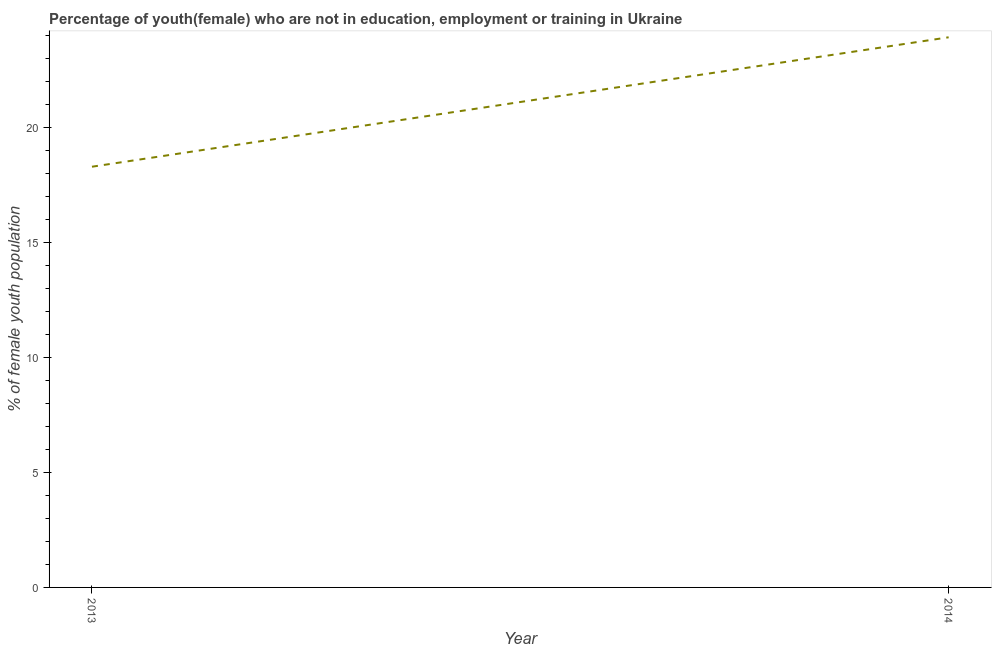What is the unemployed female youth population in 2013?
Provide a short and direct response. 18.3. Across all years, what is the maximum unemployed female youth population?
Ensure brevity in your answer.  23.93. Across all years, what is the minimum unemployed female youth population?
Provide a short and direct response. 18.3. In which year was the unemployed female youth population maximum?
Your response must be concise. 2014. In which year was the unemployed female youth population minimum?
Keep it short and to the point. 2013. What is the sum of the unemployed female youth population?
Keep it short and to the point. 42.23. What is the difference between the unemployed female youth population in 2013 and 2014?
Ensure brevity in your answer.  -5.63. What is the average unemployed female youth population per year?
Your answer should be compact. 21.11. What is the median unemployed female youth population?
Ensure brevity in your answer.  21.11. Do a majority of the years between 2013 and 2014 (inclusive) have unemployed female youth population greater than 8 %?
Offer a very short reply. Yes. What is the ratio of the unemployed female youth population in 2013 to that in 2014?
Offer a terse response. 0.76. In how many years, is the unemployed female youth population greater than the average unemployed female youth population taken over all years?
Offer a very short reply. 1. How many lines are there?
Keep it short and to the point. 1. What is the difference between two consecutive major ticks on the Y-axis?
Your answer should be compact. 5. What is the title of the graph?
Keep it short and to the point. Percentage of youth(female) who are not in education, employment or training in Ukraine. What is the label or title of the Y-axis?
Provide a succinct answer. % of female youth population. What is the % of female youth population in 2013?
Provide a short and direct response. 18.3. What is the % of female youth population of 2014?
Offer a terse response. 23.93. What is the difference between the % of female youth population in 2013 and 2014?
Provide a short and direct response. -5.63. What is the ratio of the % of female youth population in 2013 to that in 2014?
Ensure brevity in your answer.  0.77. 